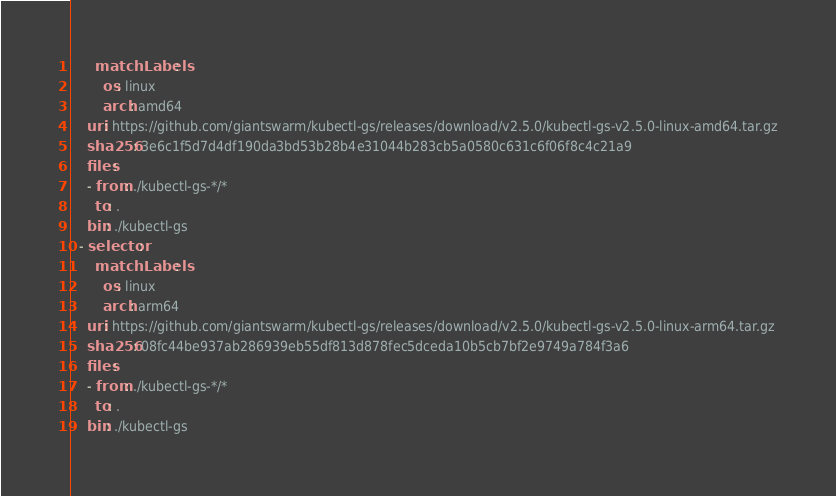<code> <loc_0><loc_0><loc_500><loc_500><_YAML_>      matchLabels:
        os: linux
        arch: amd64
    uri: https://github.com/giantswarm/kubectl-gs/releases/download/v2.5.0/kubectl-gs-v2.5.0-linux-amd64.tar.gz
    sha256: 3e6c1f5d7d4df190da3bd53b28b4e31044b283cb5a0580c631c6f06f8c4c21a9
    files:
    - from: ./kubectl-gs-*/*
      to: .
    bin: ./kubectl-gs
  - selector:
      matchLabels:
        os: linux
        arch: arm64
    uri: https://github.com/giantswarm/kubectl-gs/releases/download/v2.5.0/kubectl-gs-v2.5.0-linux-arm64.tar.gz
    sha256: 08fc44be937ab286939eb55df813d878fec5dceda10b5cb7bf2e9749a784f3a6
    files:
    - from: ./kubectl-gs-*/*
      to: .
    bin: ./kubectl-gs
</code> 